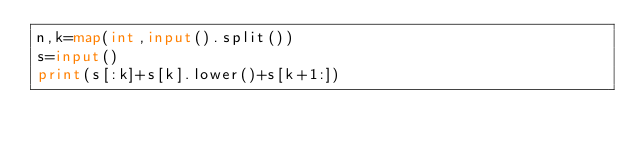Convert code to text. <code><loc_0><loc_0><loc_500><loc_500><_Python_>n,k=map(int,input().split())
s=input()
print(s[:k]+s[k].lower()+s[k+1:])</code> 